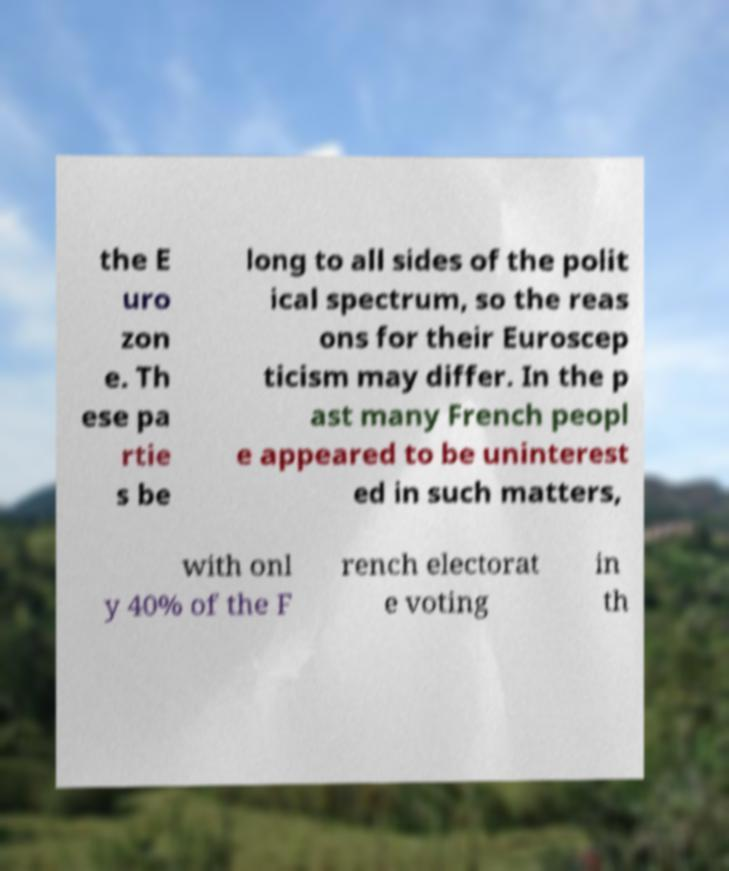What messages or text are displayed in this image? I need them in a readable, typed format. the E uro zon e. Th ese pa rtie s be long to all sides of the polit ical spectrum, so the reas ons for their Euroscep ticism may differ. In the p ast many French peopl e appeared to be uninterest ed in such matters, with onl y 40% of the F rench electorat e voting in th 